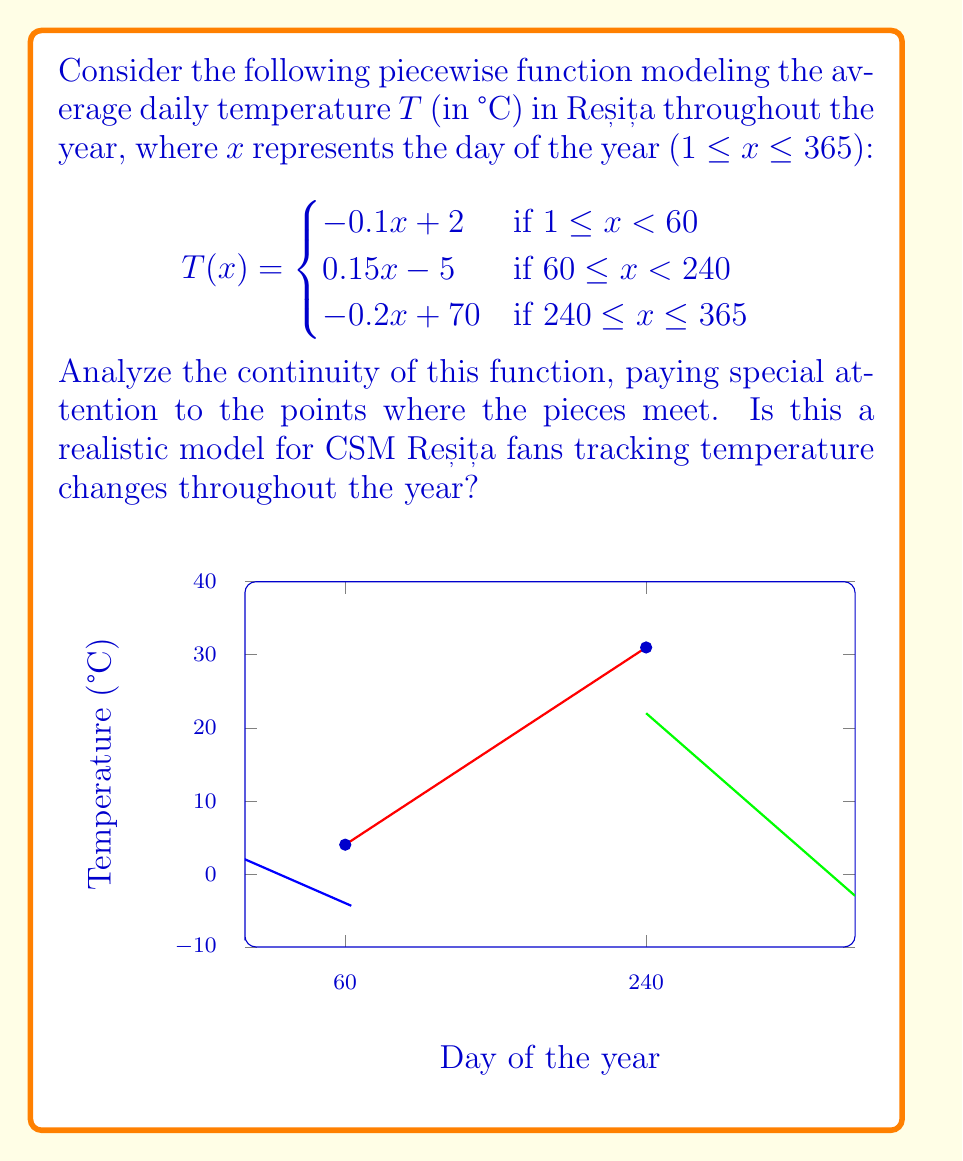Can you solve this math problem? To analyze the continuity of this piecewise function, we need to check:
1. Continuity within each piece
2. Continuity at the transition points (x = 60 and x = 240)

Step 1: Continuity within each piece
Each piece of the function is a linear function, which is continuous on its domain. So, the function is continuous within each piece.

Step 2: Continuity at x = 60
Left limit: $\lim_{x \to 60^-} T(x) = -0.1(60) + 2 = -4$
Right limit: $\lim_{x \to 60^+} T(x) = 0.15(60) - 5 = 4$
Function value: $T(60) = 0.15(60) - 5 = 4$

Since the left limit ≠ right limit, the function is discontinuous at x = 60.

Step 3: Continuity at x = 240
Left limit: $\lim_{x \to 240^-} T(x) = 0.15(240) - 5 = 31$
Right limit: $\lim_{x \to 240^+} T(x) = -0.2(240) + 70 = 22$
Function value: $T(240) = 0.15(240) - 5 = 31$

Since the left limit ≠ right limit, the function is discontinuous at x = 240.

Regarding realism: While this model captures the general trend of temperature changes in Reșița (colder in winter, warmer in summer), the discontinuities at day 60 (around March 1st) and day 240 (around August 28th) are not realistic. Real temperature changes are typically continuous, with smoother transitions between seasons. For CSM Reșița fans tracking temperatures, a continuous function would be more appropriate.
Answer: The function is discontinuous at x = 60 and x = 240, making it an unrealistic model for temperature changes in Reșița. 